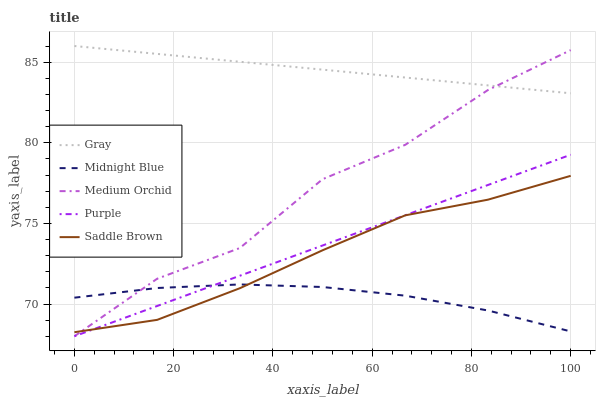Does Midnight Blue have the minimum area under the curve?
Answer yes or no. Yes. Does Gray have the maximum area under the curve?
Answer yes or no. Yes. Does Medium Orchid have the minimum area under the curve?
Answer yes or no. No. Does Medium Orchid have the maximum area under the curve?
Answer yes or no. No. Is Purple the smoothest?
Answer yes or no. Yes. Is Medium Orchid the roughest?
Answer yes or no. Yes. Is Gray the smoothest?
Answer yes or no. No. Is Gray the roughest?
Answer yes or no. No. Does Purple have the lowest value?
Answer yes or no. Yes. Does Gray have the lowest value?
Answer yes or no. No. Does Gray have the highest value?
Answer yes or no. Yes. Does Medium Orchid have the highest value?
Answer yes or no. No. Is Saddle Brown less than Gray?
Answer yes or no. Yes. Is Gray greater than Midnight Blue?
Answer yes or no. Yes. Does Midnight Blue intersect Medium Orchid?
Answer yes or no. Yes. Is Midnight Blue less than Medium Orchid?
Answer yes or no. No. Is Midnight Blue greater than Medium Orchid?
Answer yes or no. No. Does Saddle Brown intersect Gray?
Answer yes or no. No. 